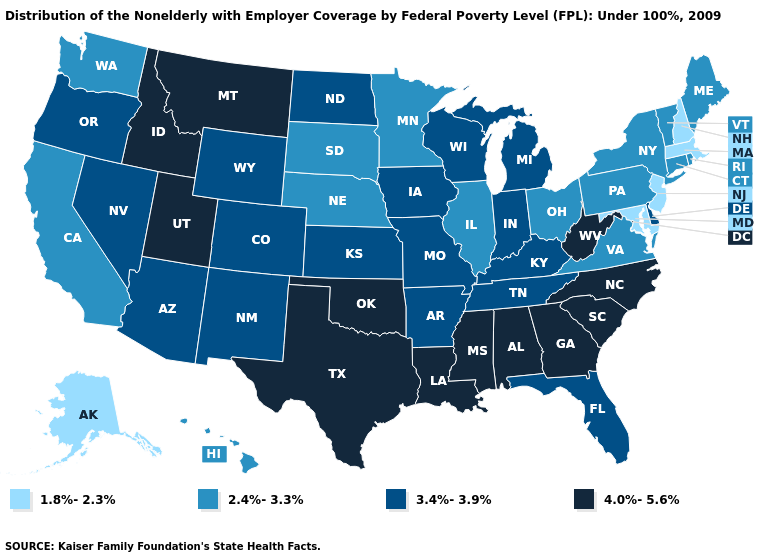How many symbols are there in the legend?
Write a very short answer. 4. Name the states that have a value in the range 2.4%-3.3%?
Short answer required. California, Connecticut, Hawaii, Illinois, Maine, Minnesota, Nebraska, New York, Ohio, Pennsylvania, Rhode Island, South Dakota, Vermont, Virginia, Washington. What is the highest value in states that border North Dakota?
Concise answer only. 4.0%-5.6%. Does Colorado have a higher value than California?
Keep it brief. Yes. Does the map have missing data?
Concise answer only. No. What is the lowest value in the USA?
Give a very brief answer. 1.8%-2.3%. Does Massachusetts have a lower value than Tennessee?
Be succinct. Yes. Name the states that have a value in the range 2.4%-3.3%?
Keep it brief. California, Connecticut, Hawaii, Illinois, Maine, Minnesota, Nebraska, New York, Ohio, Pennsylvania, Rhode Island, South Dakota, Vermont, Virginia, Washington. Name the states that have a value in the range 4.0%-5.6%?
Be succinct. Alabama, Georgia, Idaho, Louisiana, Mississippi, Montana, North Carolina, Oklahoma, South Carolina, Texas, Utah, West Virginia. Which states have the lowest value in the Northeast?
Keep it brief. Massachusetts, New Hampshire, New Jersey. Name the states that have a value in the range 3.4%-3.9%?
Concise answer only. Arizona, Arkansas, Colorado, Delaware, Florida, Indiana, Iowa, Kansas, Kentucky, Michigan, Missouri, Nevada, New Mexico, North Dakota, Oregon, Tennessee, Wisconsin, Wyoming. Name the states that have a value in the range 1.8%-2.3%?
Quick response, please. Alaska, Maryland, Massachusetts, New Hampshire, New Jersey. What is the value of Colorado?
Concise answer only. 3.4%-3.9%. What is the value of Missouri?
Answer briefly. 3.4%-3.9%. What is the lowest value in states that border North Carolina?
Answer briefly. 2.4%-3.3%. 